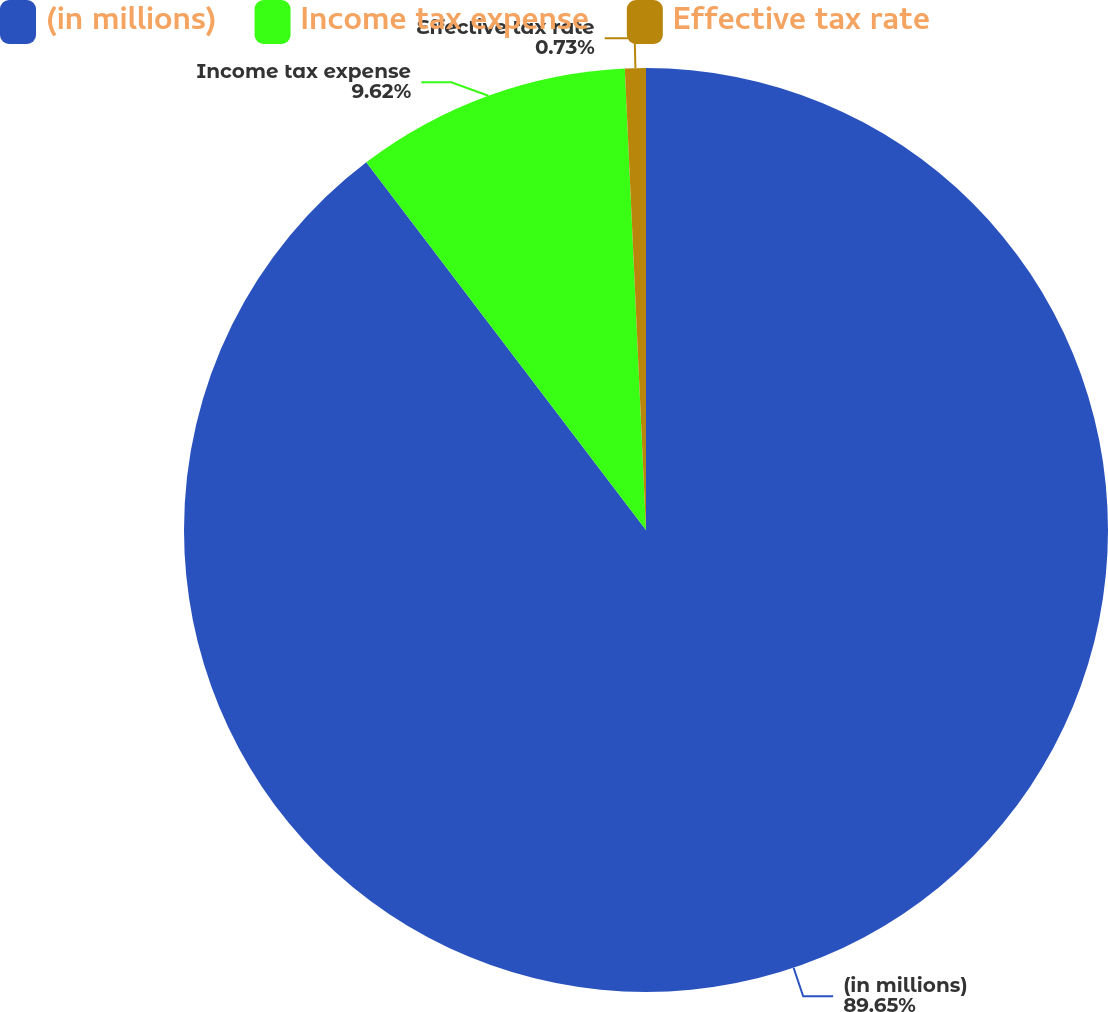Convert chart. <chart><loc_0><loc_0><loc_500><loc_500><pie_chart><fcel>(in millions)<fcel>Income tax expense<fcel>Effective tax rate<nl><fcel>89.65%<fcel>9.62%<fcel>0.73%<nl></chart> 